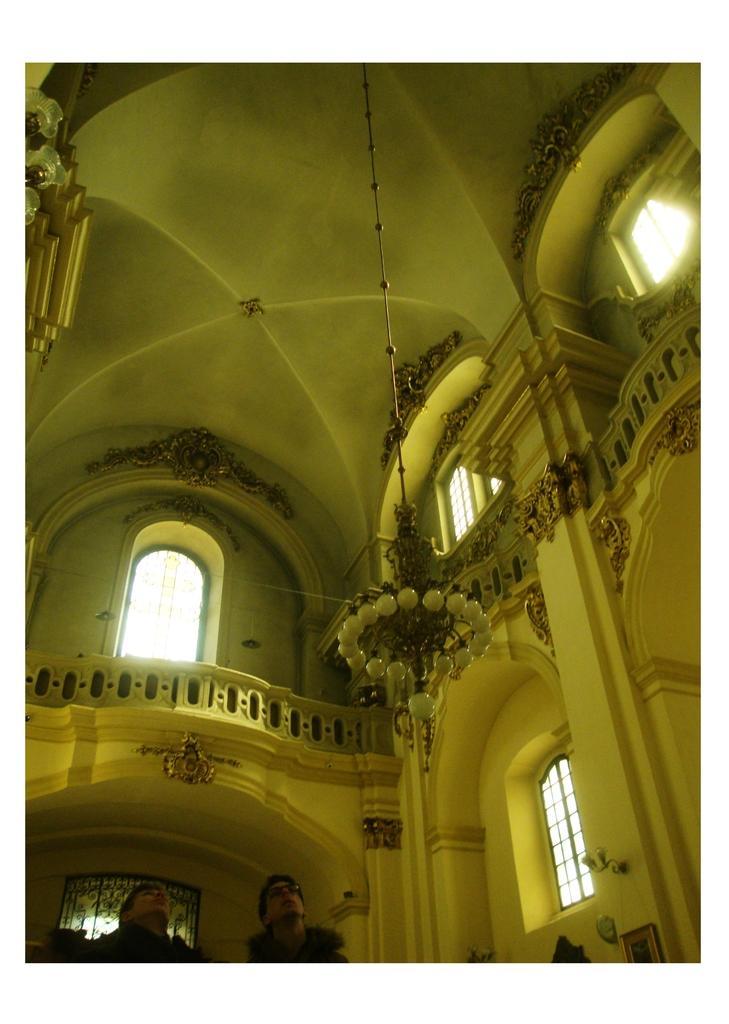In one or two sentences, can you explain what this image depicts? In this image, we can see the inner view of a building. There are a few people. We can see the wall with some windows and sculptures. We can also see a light attached at the top. We can see some objects on the left. 